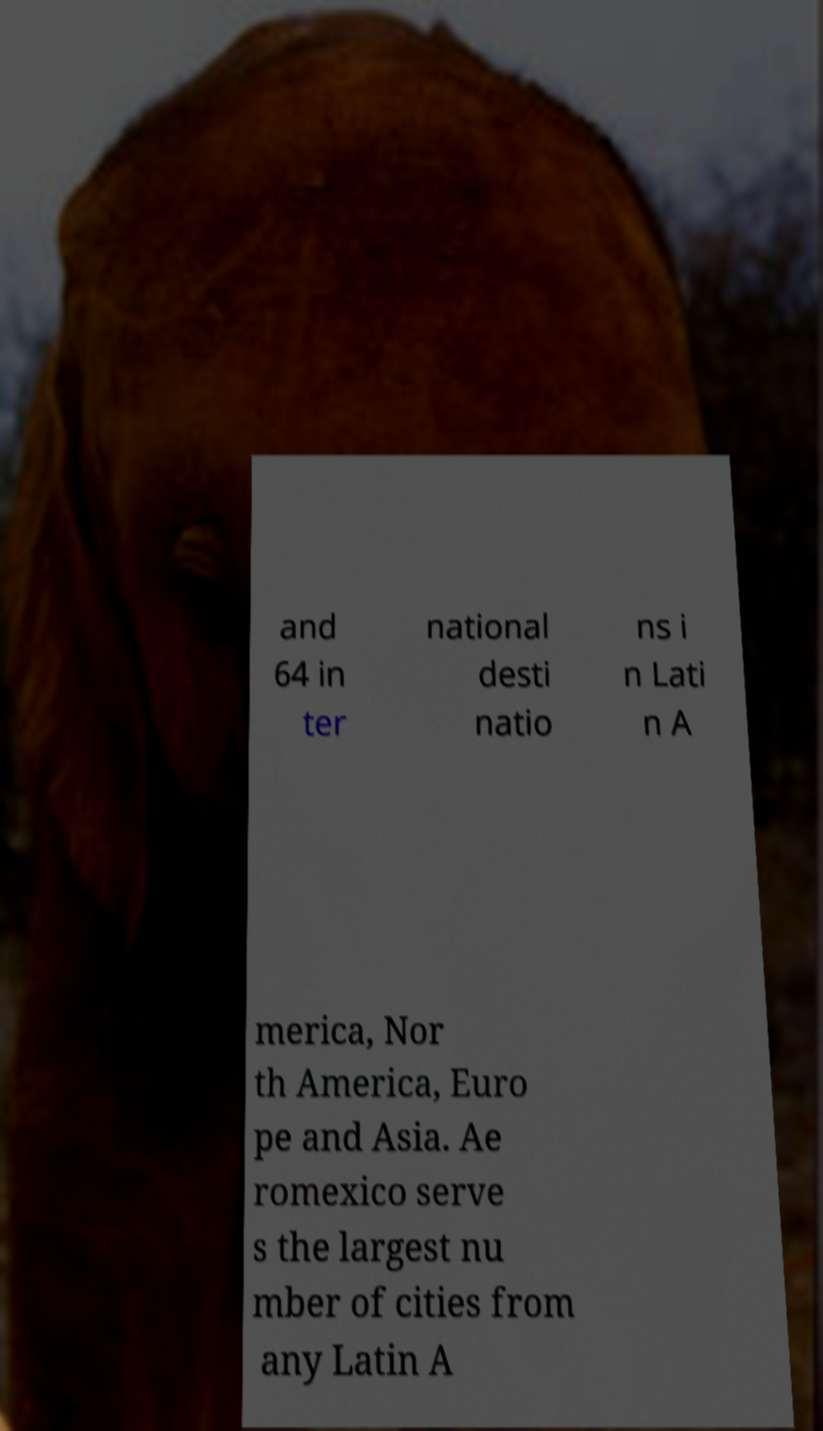Please read and relay the text visible in this image. What does it say? and 64 in ter national desti natio ns i n Lati n A merica, Nor th America, Euro pe and Asia. Ae romexico serve s the largest nu mber of cities from any Latin A 